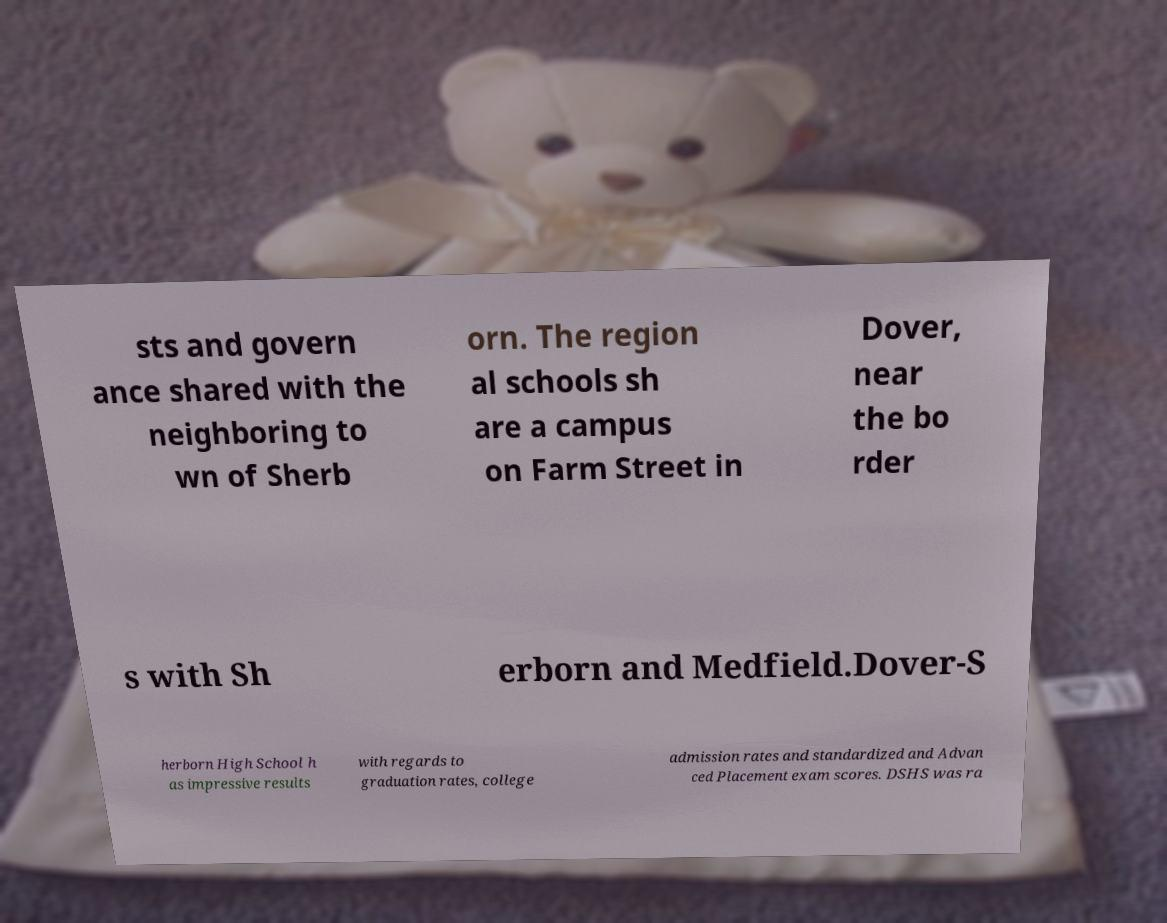Please read and relay the text visible in this image. What does it say? sts and govern ance shared with the neighboring to wn of Sherb orn. The region al schools sh are a campus on Farm Street in Dover, near the bo rder s with Sh erborn and Medfield.Dover-S herborn High School h as impressive results with regards to graduation rates, college admission rates and standardized and Advan ced Placement exam scores. DSHS was ra 